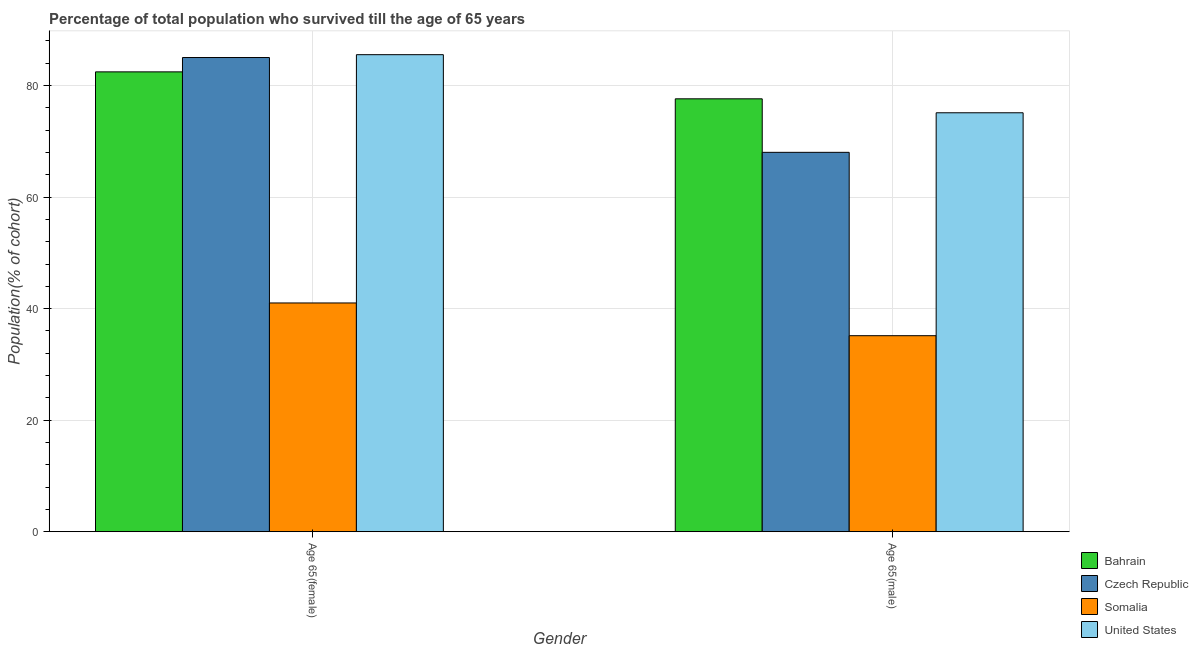How many groups of bars are there?
Offer a very short reply. 2. What is the label of the 2nd group of bars from the left?
Provide a succinct answer. Age 65(male). What is the percentage of male population who survived till age of 65 in United States?
Offer a very short reply. 75.12. Across all countries, what is the maximum percentage of male population who survived till age of 65?
Give a very brief answer. 77.62. Across all countries, what is the minimum percentage of female population who survived till age of 65?
Your response must be concise. 41.02. In which country was the percentage of female population who survived till age of 65 maximum?
Give a very brief answer. United States. In which country was the percentage of female population who survived till age of 65 minimum?
Ensure brevity in your answer.  Somalia. What is the total percentage of female population who survived till age of 65 in the graph?
Your answer should be very brief. 294.02. What is the difference between the percentage of male population who survived till age of 65 in Somalia and that in United States?
Offer a terse response. -39.97. What is the difference between the percentage of female population who survived till age of 65 in United States and the percentage of male population who survived till age of 65 in Bahrain?
Offer a very short reply. 7.91. What is the average percentage of female population who survived till age of 65 per country?
Keep it short and to the point. 73.51. What is the difference between the percentage of female population who survived till age of 65 and percentage of male population who survived till age of 65 in United States?
Give a very brief answer. 10.42. What is the ratio of the percentage of female population who survived till age of 65 in Somalia to that in Czech Republic?
Your answer should be compact. 0.48. In how many countries, is the percentage of male population who survived till age of 65 greater than the average percentage of male population who survived till age of 65 taken over all countries?
Your answer should be very brief. 3. What does the 3rd bar from the left in Age 65(male) represents?
Give a very brief answer. Somalia. What does the 4th bar from the right in Age 65(female) represents?
Ensure brevity in your answer.  Bahrain. How many bars are there?
Make the answer very short. 8. Are all the bars in the graph horizontal?
Make the answer very short. No. Are the values on the major ticks of Y-axis written in scientific E-notation?
Give a very brief answer. No. Does the graph contain any zero values?
Keep it short and to the point. No. Does the graph contain grids?
Your answer should be very brief. Yes. Where does the legend appear in the graph?
Make the answer very short. Bottom right. How many legend labels are there?
Provide a short and direct response. 4. How are the legend labels stacked?
Provide a succinct answer. Vertical. What is the title of the graph?
Give a very brief answer. Percentage of total population who survived till the age of 65 years. What is the label or title of the Y-axis?
Give a very brief answer. Population(% of cohort). What is the Population(% of cohort) in Bahrain in Age 65(female)?
Your response must be concise. 82.45. What is the Population(% of cohort) of Czech Republic in Age 65(female)?
Provide a succinct answer. 85.02. What is the Population(% of cohort) of Somalia in Age 65(female)?
Offer a terse response. 41.02. What is the Population(% of cohort) in United States in Age 65(female)?
Ensure brevity in your answer.  85.53. What is the Population(% of cohort) of Bahrain in Age 65(male)?
Keep it short and to the point. 77.62. What is the Population(% of cohort) in Czech Republic in Age 65(male)?
Ensure brevity in your answer.  68.02. What is the Population(% of cohort) of Somalia in Age 65(male)?
Make the answer very short. 35.15. What is the Population(% of cohort) of United States in Age 65(male)?
Ensure brevity in your answer.  75.12. Across all Gender, what is the maximum Population(% of cohort) in Bahrain?
Offer a terse response. 82.45. Across all Gender, what is the maximum Population(% of cohort) in Czech Republic?
Keep it short and to the point. 85.02. Across all Gender, what is the maximum Population(% of cohort) in Somalia?
Offer a terse response. 41.02. Across all Gender, what is the maximum Population(% of cohort) in United States?
Give a very brief answer. 85.53. Across all Gender, what is the minimum Population(% of cohort) of Bahrain?
Provide a succinct answer. 77.62. Across all Gender, what is the minimum Population(% of cohort) in Czech Republic?
Your response must be concise. 68.02. Across all Gender, what is the minimum Population(% of cohort) of Somalia?
Give a very brief answer. 35.15. Across all Gender, what is the minimum Population(% of cohort) of United States?
Offer a very short reply. 75.12. What is the total Population(% of cohort) of Bahrain in the graph?
Your response must be concise. 160.07. What is the total Population(% of cohort) of Czech Republic in the graph?
Offer a very short reply. 153.04. What is the total Population(% of cohort) of Somalia in the graph?
Your answer should be compact. 76.16. What is the total Population(% of cohort) of United States in the graph?
Make the answer very short. 160.65. What is the difference between the Population(% of cohort) in Bahrain in Age 65(female) and that in Age 65(male)?
Give a very brief answer. 4.83. What is the difference between the Population(% of cohort) of Czech Republic in Age 65(female) and that in Age 65(male)?
Your answer should be very brief. 17. What is the difference between the Population(% of cohort) of Somalia in Age 65(female) and that in Age 65(male)?
Give a very brief answer. 5.87. What is the difference between the Population(% of cohort) of United States in Age 65(female) and that in Age 65(male)?
Your answer should be compact. 10.42. What is the difference between the Population(% of cohort) in Bahrain in Age 65(female) and the Population(% of cohort) in Czech Republic in Age 65(male)?
Offer a very short reply. 14.43. What is the difference between the Population(% of cohort) in Bahrain in Age 65(female) and the Population(% of cohort) in Somalia in Age 65(male)?
Offer a very short reply. 47.3. What is the difference between the Population(% of cohort) in Bahrain in Age 65(female) and the Population(% of cohort) in United States in Age 65(male)?
Offer a very short reply. 7.34. What is the difference between the Population(% of cohort) of Czech Republic in Age 65(female) and the Population(% of cohort) of Somalia in Age 65(male)?
Keep it short and to the point. 49.88. What is the difference between the Population(% of cohort) in Czech Republic in Age 65(female) and the Population(% of cohort) in United States in Age 65(male)?
Your response must be concise. 9.91. What is the difference between the Population(% of cohort) in Somalia in Age 65(female) and the Population(% of cohort) in United States in Age 65(male)?
Your response must be concise. -34.1. What is the average Population(% of cohort) in Bahrain per Gender?
Your answer should be very brief. 80.03. What is the average Population(% of cohort) in Czech Republic per Gender?
Your answer should be compact. 76.52. What is the average Population(% of cohort) in Somalia per Gender?
Offer a very short reply. 38.08. What is the average Population(% of cohort) in United States per Gender?
Ensure brevity in your answer.  80.32. What is the difference between the Population(% of cohort) of Bahrain and Population(% of cohort) of Czech Republic in Age 65(female)?
Your answer should be compact. -2.57. What is the difference between the Population(% of cohort) in Bahrain and Population(% of cohort) in Somalia in Age 65(female)?
Give a very brief answer. 41.43. What is the difference between the Population(% of cohort) of Bahrain and Population(% of cohort) of United States in Age 65(female)?
Your answer should be very brief. -3.08. What is the difference between the Population(% of cohort) of Czech Republic and Population(% of cohort) of Somalia in Age 65(female)?
Your answer should be very brief. 44.01. What is the difference between the Population(% of cohort) in Czech Republic and Population(% of cohort) in United States in Age 65(female)?
Your answer should be very brief. -0.51. What is the difference between the Population(% of cohort) of Somalia and Population(% of cohort) of United States in Age 65(female)?
Ensure brevity in your answer.  -44.52. What is the difference between the Population(% of cohort) of Bahrain and Population(% of cohort) of Czech Republic in Age 65(male)?
Your answer should be very brief. 9.6. What is the difference between the Population(% of cohort) in Bahrain and Population(% of cohort) in Somalia in Age 65(male)?
Give a very brief answer. 42.47. What is the difference between the Population(% of cohort) in Bahrain and Population(% of cohort) in United States in Age 65(male)?
Your answer should be very brief. 2.5. What is the difference between the Population(% of cohort) in Czech Republic and Population(% of cohort) in Somalia in Age 65(male)?
Your answer should be compact. 32.88. What is the difference between the Population(% of cohort) in Czech Republic and Population(% of cohort) in United States in Age 65(male)?
Your answer should be compact. -7.09. What is the difference between the Population(% of cohort) in Somalia and Population(% of cohort) in United States in Age 65(male)?
Offer a very short reply. -39.97. What is the ratio of the Population(% of cohort) in Bahrain in Age 65(female) to that in Age 65(male)?
Offer a very short reply. 1.06. What is the ratio of the Population(% of cohort) of Czech Republic in Age 65(female) to that in Age 65(male)?
Provide a succinct answer. 1.25. What is the ratio of the Population(% of cohort) of Somalia in Age 65(female) to that in Age 65(male)?
Offer a very short reply. 1.17. What is the ratio of the Population(% of cohort) of United States in Age 65(female) to that in Age 65(male)?
Give a very brief answer. 1.14. What is the difference between the highest and the second highest Population(% of cohort) of Bahrain?
Your answer should be very brief. 4.83. What is the difference between the highest and the second highest Population(% of cohort) in Czech Republic?
Provide a succinct answer. 17. What is the difference between the highest and the second highest Population(% of cohort) of Somalia?
Ensure brevity in your answer.  5.87. What is the difference between the highest and the second highest Population(% of cohort) in United States?
Your answer should be compact. 10.42. What is the difference between the highest and the lowest Population(% of cohort) in Bahrain?
Give a very brief answer. 4.83. What is the difference between the highest and the lowest Population(% of cohort) of Czech Republic?
Offer a very short reply. 17. What is the difference between the highest and the lowest Population(% of cohort) of Somalia?
Provide a short and direct response. 5.87. What is the difference between the highest and the lowest Population(% of cohort) in United States?
Offer a very short reply. 10.42. 